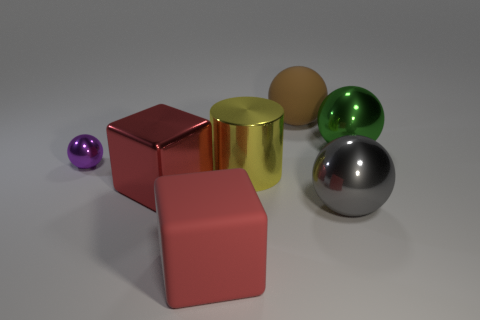Subtract 1 spheres. How many spheres are left? 3 Subtract all big balls. How many balls are left? 1 Subtract all gray spheres. How many spheres are left? 3 Subtract all yellow balls. Subtract all yellow blocks. How many balls are left? 4 Add 3 matte things. How many objects exist? 10 Subtract all cubes. How many objects are left? 5 Add 4 big green shiny things. How many big green shiny things are left? 5 Add 2 big metallic things. How many big metallic things exist? 6 Subtract 1 red blocks. How many objects are left? 6 Subtract all small purple shiny objects. Subtract all large green spheres. How many objects are left? 5 